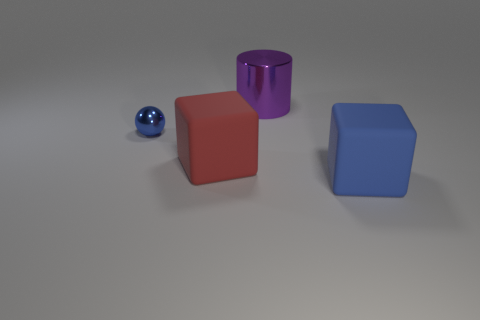Subtract 1 blocks. How many blocks are left? 1 Add 3 purple shiny things. How many objects exist? 7 Subtract all red blocks. How many blocks are left? 1 Subtract 1 blue balls. How many objects are left? 3 Subtract all red balls. Subtract all gray blocks. How many balls are left? 1 Subtract all brown spheres. How many red cubes are left? 1 Subtract all small blue things. Subtract all tiny blue metallic balls. How many objects are left? 2 Add 4 small blue metal spheres. How many small blue metal spheres are left? 5 Add 4 cyan metallic spheres. How many cyan metallic spheres exist? 4 